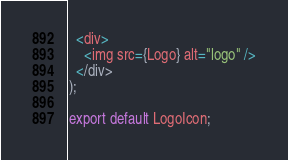Convert code to text. <code><loc_0><loc_0><loc_500><loc_500><_JavaScript_>  <div>
    <img src={Logo} alt="logo" />
  </div>
);

export default LogoIcon;
</code> 